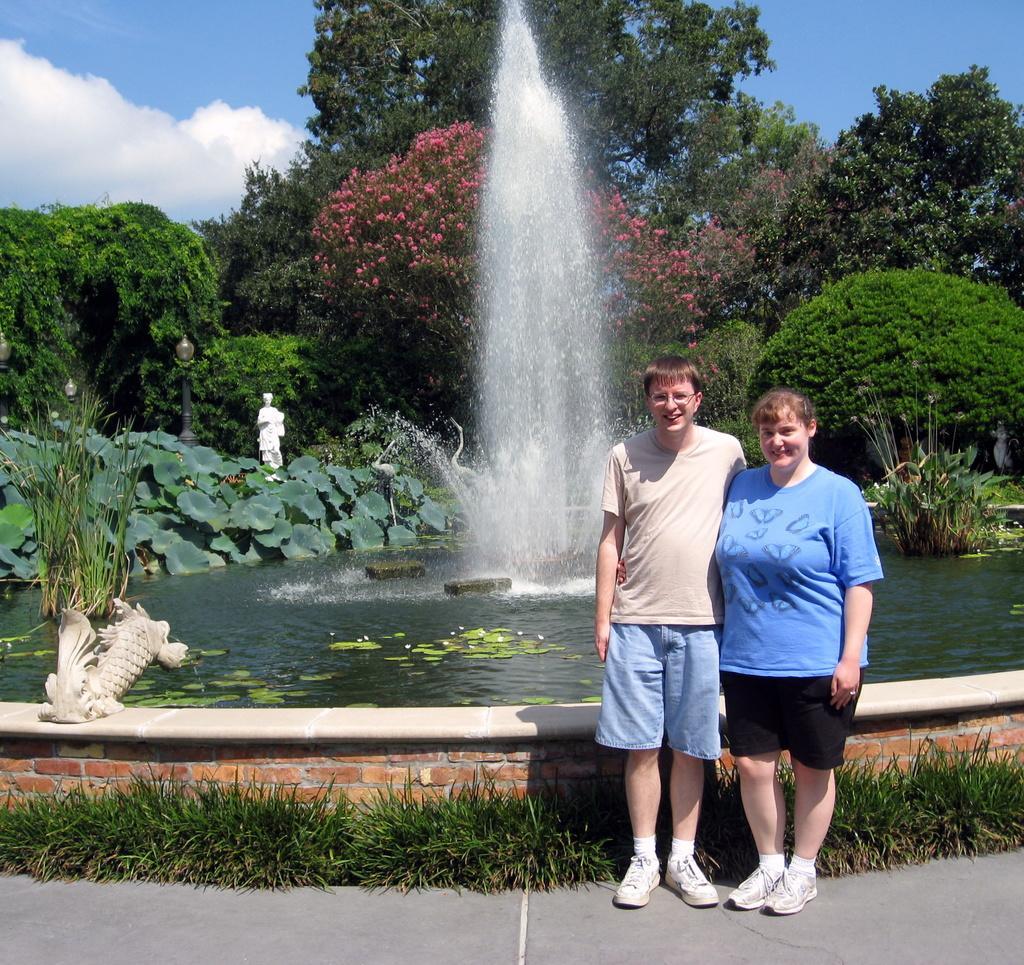In one or two sentences, can you explain what this image depicts? In this image there are two persons standing and smiling , there is a water fountain, grass,there are plants, sculptures , there are trees, and in the background there is sky. 